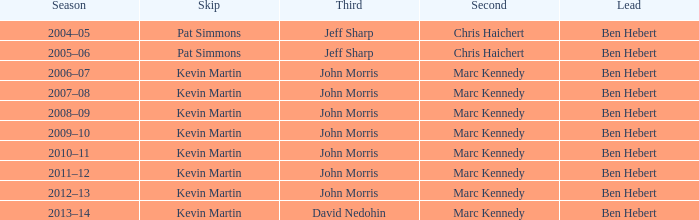What guidance has the third david nedohin provided? Ben Hebert. 